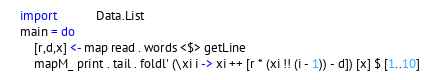<code> <loc_0><loc_0><loc_500><loc_500><_Haskell_>import           Data.List
main = do
    [r,d,x] <- map read . words <$> getLine
    mapM_ print . tail . foldl' (\xi i -> xi ++ [r * (xi !! (i - 1)) - d]) [x] $ [1..10]
</code> 